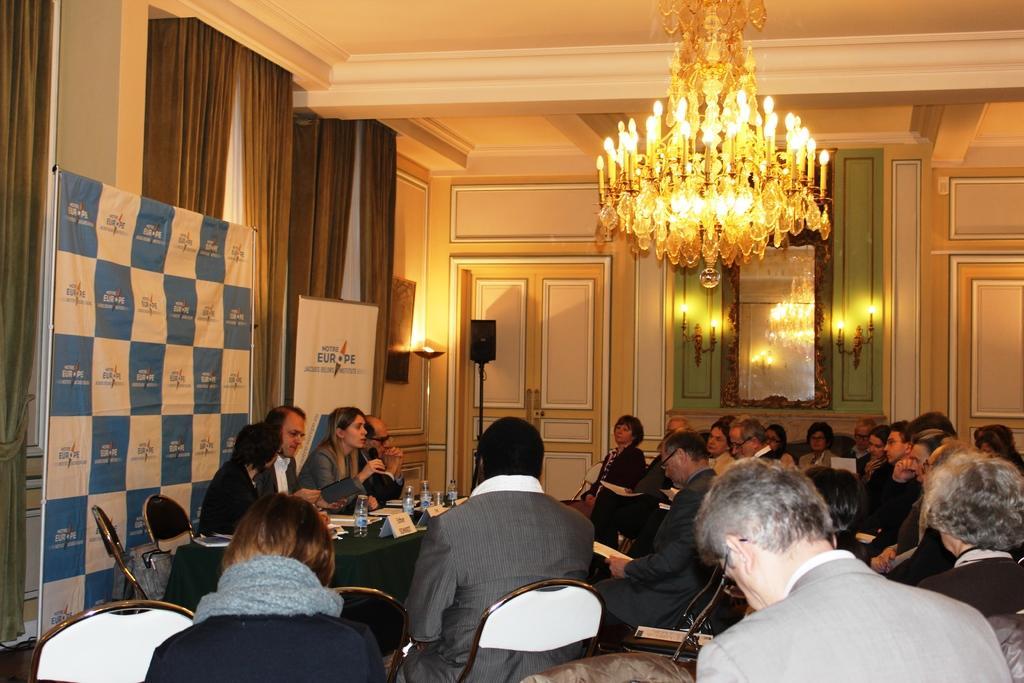Can you describe this image briefly? In this image we can see a group of people sitting on chairs. On the left side of the image we can see a woman holding a microphone in her hand, group of boards with text, bottles and papers are placed on the table. In the background, we can see banners with text are placed on the floor, speaker on a stand, lights, a mirror on the wall and some curtains. At the top of the image we can see the chandelier. 